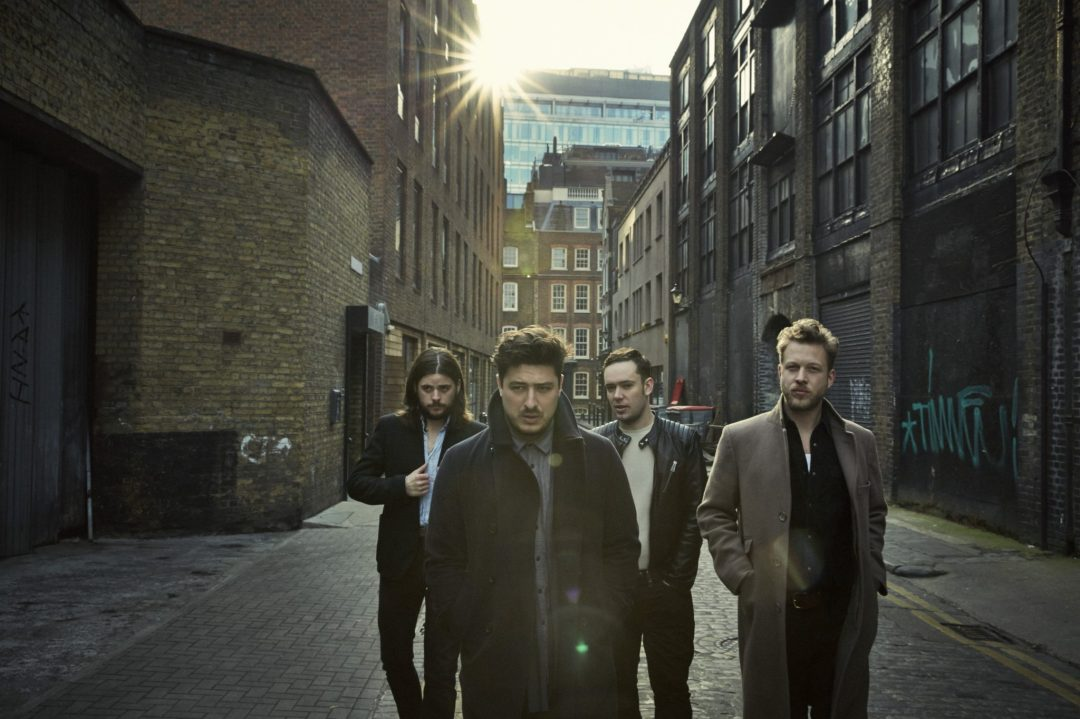Based on the attire and grooming styles of the individuals in the image, what time of year does it appear to be and what might be the group's purpose for being in this alleyway? The individuals in the image are wearing coats and layered clothing, with one sporting a scarf, indicating that it's likely to be a cooler time of year, such as late autumn or early spring. Their style is quite cohesive, suggesting they may be a professional group possibly conducting a photoshoot or filming a music video. The alleyway provides an industrial, gritty backdrop that's often sought after for its character and texture in visual media. 